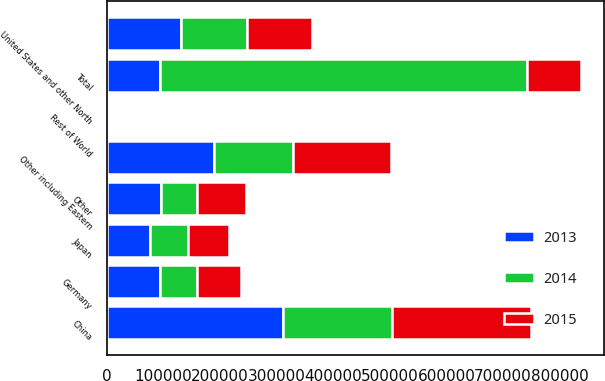Convert chart to OTSL. <chart><loc_0><loc_0><loc_500><loc_500><stacked_bar_chart><ecel><fcel>United States and other North<fcel>Germany<fcel>Other including Eastern<fcel>Japan<fcel>China<fcel>Other<fcel>Rest of World<fcel>Total<nl><fcel>2013<fcel>131525<fcel>93802<fcel>189123<fcel>76033<fcel>311946<fcel>95494<fcel>3342<fcel>94648<nl><fcel>2015<fcel>113233<fcel>77404<fcel>173018<fcel>72573<fcel>245102<fcel>85426<fcel>3076<fcel>94648<nl><fcel>2014<fcel>116935<fcel>65147<fcel>140279<fcel>67981<fcel>192134<fcel>64346<fcel>1212<fcel>648034<nl></chart> 